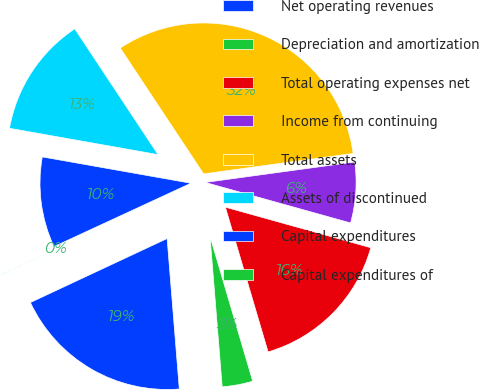Convert chart to OTSL. <chart><loc_0><loc_0><loc_500><loc_500><pie_chart><fcel>Net operating revenues<fcel>Depreciation and amortization<fcel>Total operating expenses net<fcel>Income from continuing<fcel>Total assets<fcel>Assets of discontinued<fcel>Capital expenditures<fcel>Capital expenditures of<nl><fcel>19.32%<fcel>3.28%<fcel>16.11%<fcel>6.49%<fcel>32.15%<fcel>12.9%<fcel>9.69%<fcel>0.07%<nl></chart> 